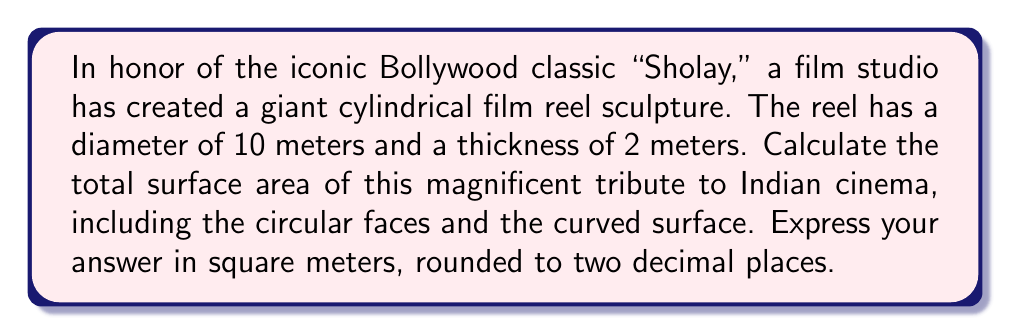Solve this math problem. To solve this problem, let's break it down step-by-step:

1) For a cylinder, we need to calculate:
   a) The area of two circular faces
   b) The area of the curved surface

2) Let's define our variables:
   $r$ = radius of the circular face = 5 meters (since diameter is 10 meters)
   $h$ = height (thickness) of the cylinder = 2 meters

3) Area of one circular face:
   $$A_{circle} = \pi r^2 = \pi (5)^2 = 25\pi \text{ m}^2$$

4) Area of two circular faces:
   $$A_{circles} = 2 \times 25\pi = 50\pi \text{ m}^2$$

5) Area of the curved surface:
   The curved surface when "unrolled" forms a rectangle.
   Width of this rectangle = circumference of the circular face = $2\pi r$
   Height of this rectangle = height of the cylinder = $h$
   
   $$A_{curved} = 2\pi r h = 2\pi (5)(2) = 20\pi \text{ m}^2$$

6) Total surface area:
   $$A_{total} = A_{circles} + A_{curved} = 50\pi + 20\pi = 70\pi \text{ m}^2$$

7) Converting to numerical value and rounding to two decimal places:
   $$A_{total} = 70 \times 3.14159... \approx 219.91 \text{ m}^2$$

[asy]
import geometry;

size(200);

// Draw the cylinder
path p = circle((0,0),50);
draw(p);
draw(shift(0,10)*p,dashed);
draw((-50,0)--(-50,10));
draw((50,0)--(50,10));

// Label dimensions
label("10 m", (0,-55), S);
draw((-40,0)--(40,0), Arrow);
draw((40,0)--(-40,0), Arrow);

label("2 m", (55,5), E);
draw((52,0)--(52,10), Arrow);
draw((52,10)--(52,0), Arrow);
[/asy]
Answer: The total surface area of the cylindrical Bollywood film reel sculpture is approximately 219.91 square meters. 